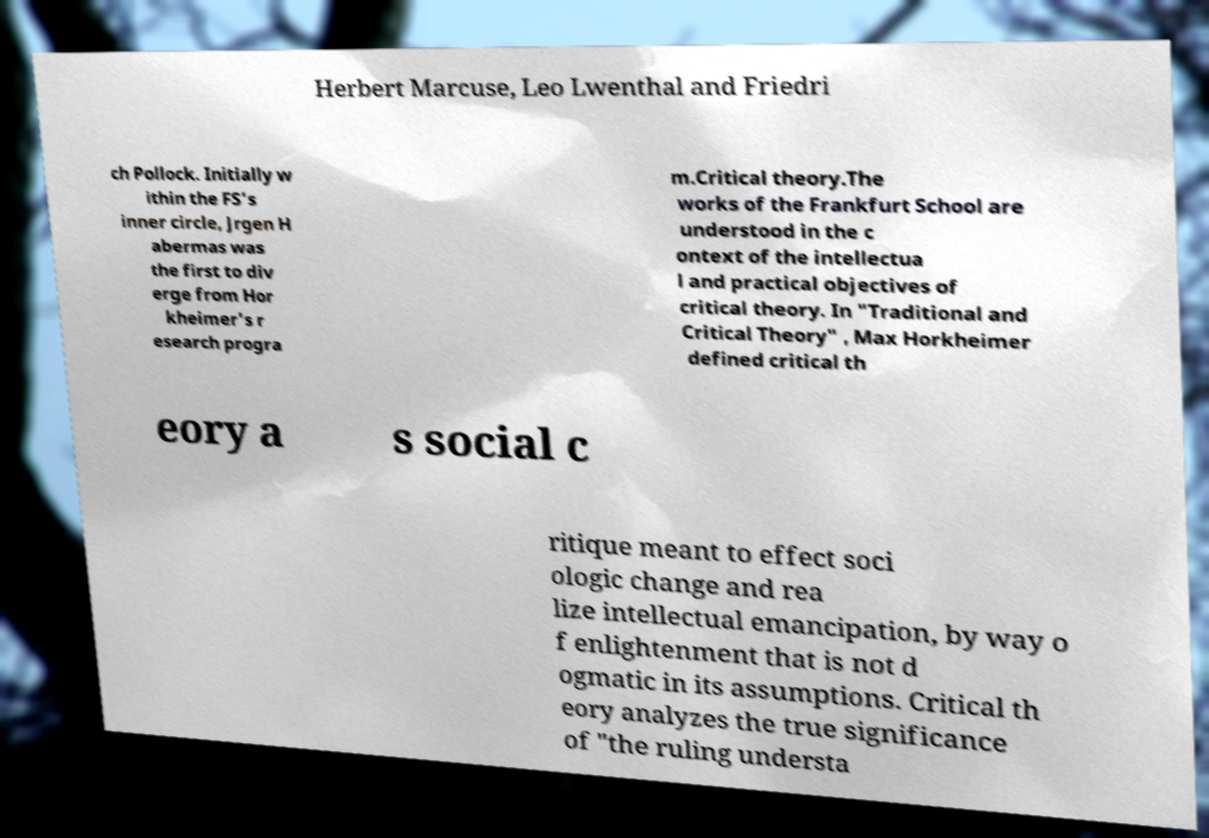Please identify and transcribe the text found in this image. Herbert Marcuse, Leo Lwenthal and Friedri ch Pollock. Initially w ithin the FS's inner circle, Jrgen H abermas was the first to div erge from Hor kheimer's r esearch progra m.Critical theory.The works of the Frankfurt School are understood in the c ontext of the intellectua l and practical objectives of critical theory. In "Traditional and Critical Theory" , Max Horkheimer defined critical th eory a s social c ritique meant to effect soci ologic change and rea lize intellectual emancipation, by way o f enlightenment that is not d ogmatic in its assumptions. Critical th eory analyzes the true significance of "the ruling understa 